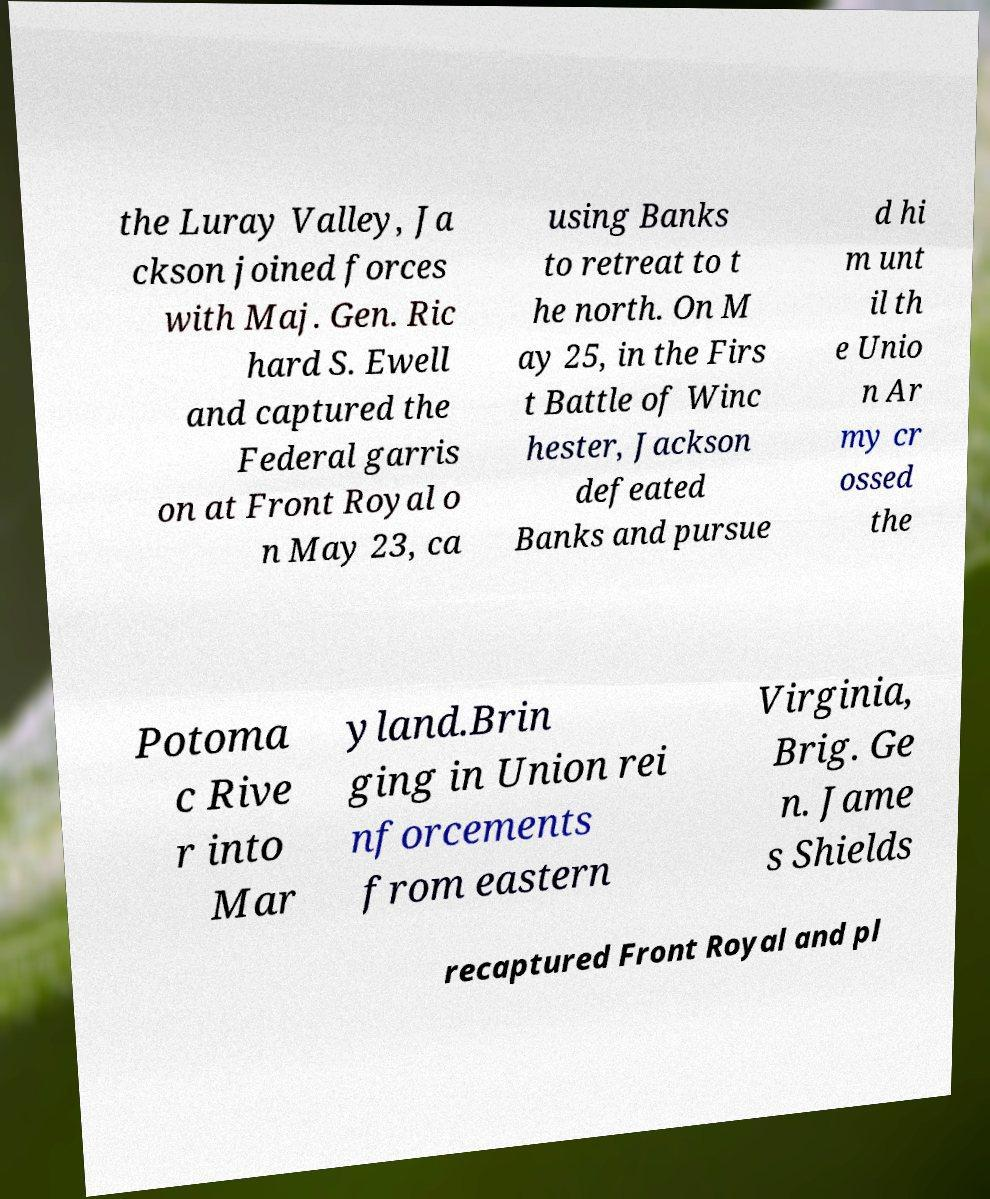Please identify and transcribe the text found in this image. the Luray Valley, Ja ckson joined forces with Maj. Gen. Ric hard S. Ewell and captured the Federal garris on at Front Royal o n May 23, ca using Banks to retreat to t he north. On M ay 25, in the Firs t Battle of Winc hester, Jackson defeated Banks and pursue d hi m unt il th e Unio n Ar my cr ossed the Potoma c Rive r into Mar yland.Brin ging in Union rei nforcements from eastern Virginia, Brig. Ge n. Jame s Shields recaptured Front Royal and pl 